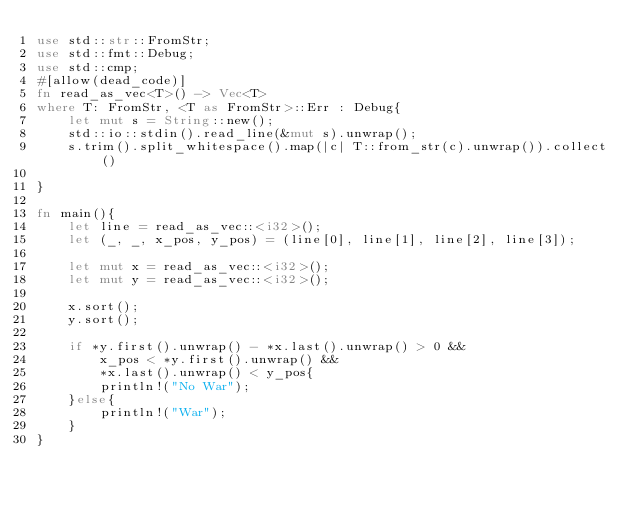<code> <loc_0><loc_0><loc_500><loc_500><_Rust_>use std::str::FromStr;
use std::fmt::Debug;
use std::cmp;
#[allow(dead_code)]
fn read_as_vec<T>() -> Vec<T>
where T: FromStr, <T as FromStr>::Err : Debug{
    let mut s = String::new();
    std::io::stdin().read_line(&mut s).unwrap();
    s.trim().split_whitespace().map(|c| T::from_str(c).unwrap()).collect()

}

fn main(){
    let line = read_as_vec::<i32>();
    let (_, _, x_pos, y_pos) = (line[0], line[1], line[2], line[3]);

    let mut x = read_as_vec::<i32>();
    let mut y = read_as_vec::<i32>();

    x.sort();
    y.sort();

    if *y.first().unwrap() - *x.last().unwrap() > 0 &&
        x_pos < *y.first().unwrap() &&
        *x.last().unwrap() < y_pos{
        println!("No War");
    }else{
        println!("War");
    }
}
</code> 